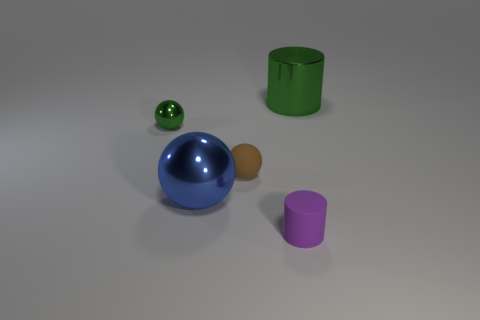There is a object that is the same color as the small shiny ball; what size is it?
Your response must be concise. Large. Is the green cylinder the same size as the purple cylinder?
Offer a very short reply. No. Is there a thing of the same color as the big cylinder?
Your answer should be very brief. Yes. There is a green metal thing left of the purple matte thing; is it the same size as the green shiny thing that is to the right of the purple matte cylinder?
Your answer should be very brief. No. There is a metallic object that is right of the tiny green thing and behind the blue metal ball; how big is it?
Give a very brief answer. Large. Is the color of the big cylinder the same as the metallic ball that is behind the blue object?
Ensure brevity in your answer.  Yes. Is there anything else of the same color as the small metallic sphere?
Give a very brief answer. Yes. There is a tiny purple cylinder; are there any tiny metallic spheres behind it?
Provide a short and direct response. Yes. Is there another big thing that has the same shape as the big blue thing?
Your answer should be compact. No. What shape is the green shiny object that is the same size as the blue sphere?
Your answer should be compact. Cylinder. 